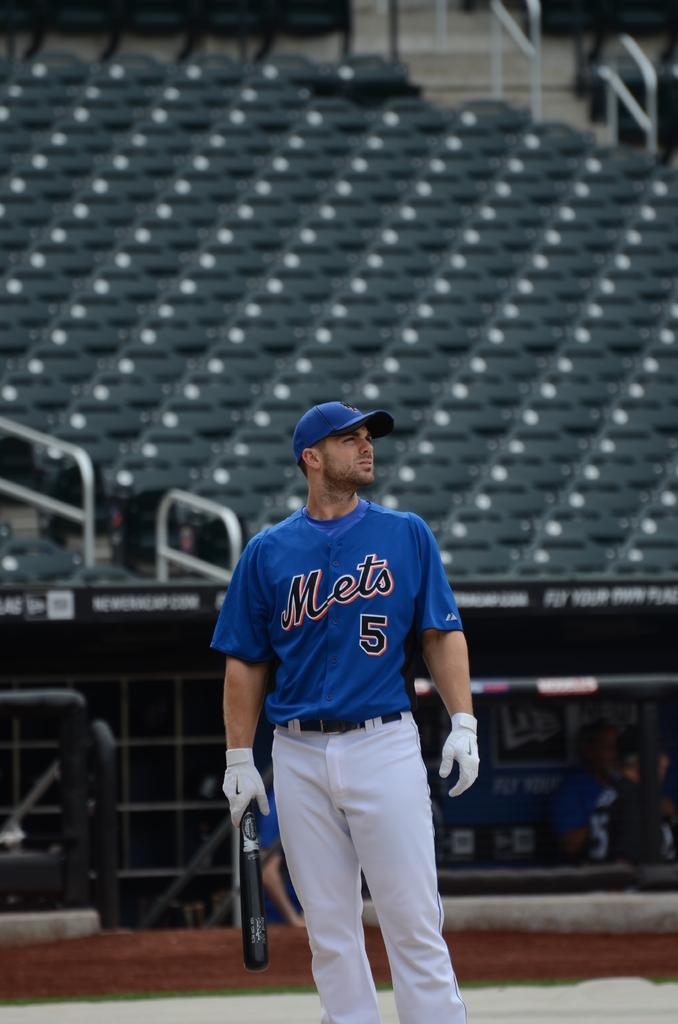<image>
Give a short and clear explanation of the subsequent image. a person that is wearing a Mets jersey with the number 5 